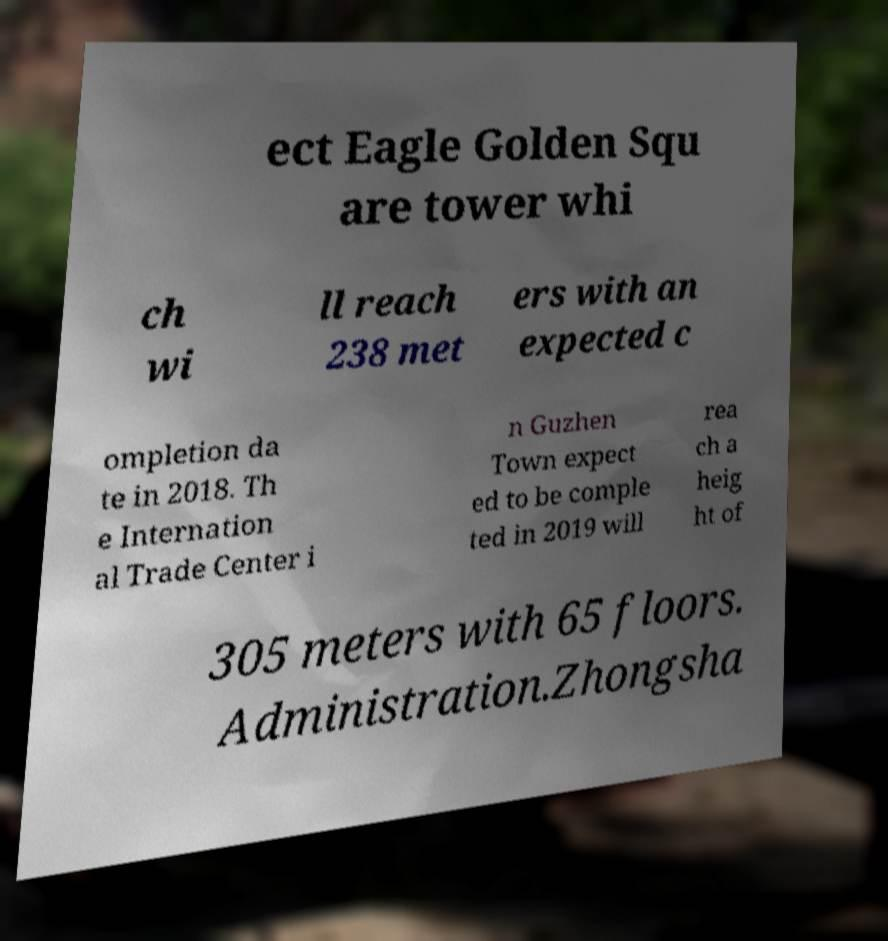Can you accurately transcribe the text from the provided image for me? ect Eagle Golden Squ are tower whi ch wi ll reach 238 met ers with an expected c ompletion da te in 2018. Th e Internation al Trade Center i n Guzhen Town expect ed to be comple ted in 2019 will rea ch a heig ht of 305 meters with 65 floors. Administration.Zhongsha 